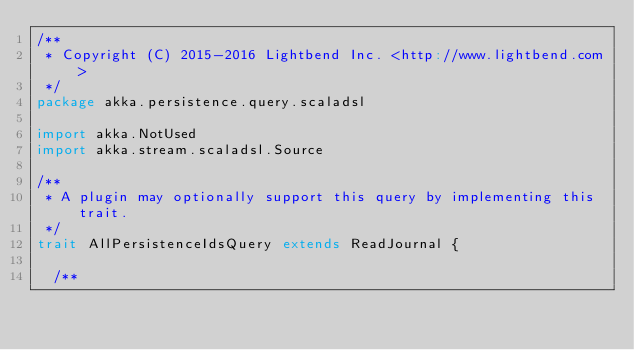Convert code to text. <code><loc_0><loc_0><loc_500><loc_500><_Scala_>/**
 * Copyright (C) 2015-2016 Lightbend Inc. <http://www.lightbend.com>
 */
package akka.persistence.query.scaladsl

import akka.NotUsed
import akka.stream.scaladsl.Source

/**
 * A plugin may optionally support this query by implementing this trait.
 */
trait AllPersistenceIdsQuery extends ReadJournal {

  /**</code> 